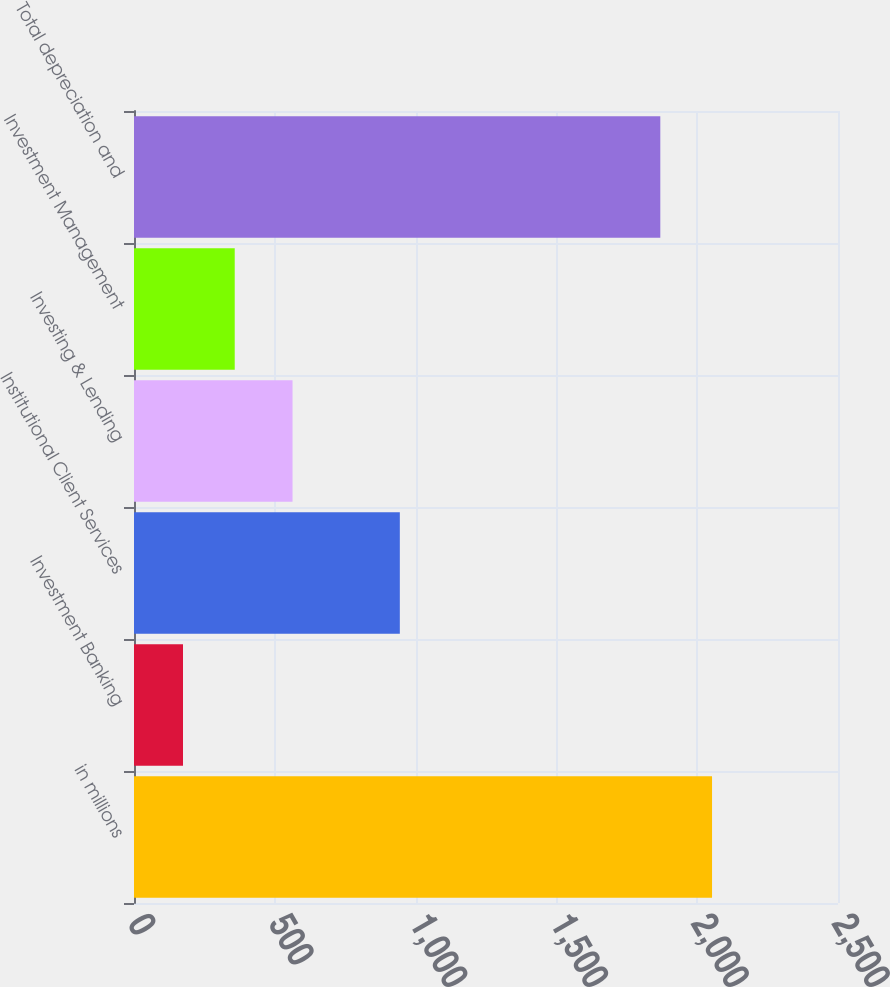Convert chart to OTSL. <chart><loc_0><loc_0><loc_500><loc_500><bar_chart><fcel>in millions<fcel>Investment Banking<fcel>Institutional Client Services<fcel>Investing & Lending<fcel>Investment Management<fcel>Total depreciation and<nl><fcel>2052.7<fcel>174<fcel>944<fcel>563<fcel>357.7<fcel>1869<nl></chart> 